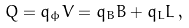Convert formula to latex. <formula><loc_0><loc_0><loc_500><loc_500>Q = q _ { \phi } V = q _ { B } B + q _ { L } L \, ,</formula> 